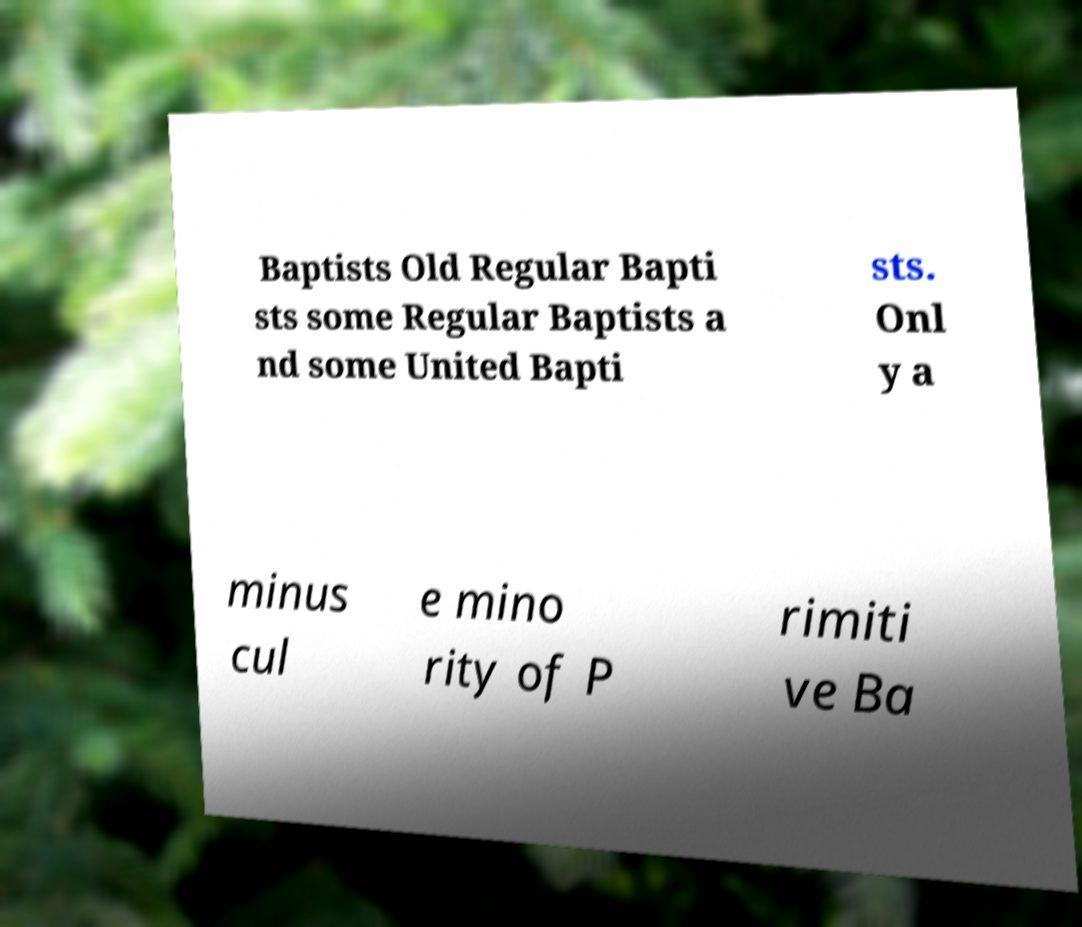What messages or text are displayed in this image? I need them in a readable, typed format. Baptists Old Regular Bapti sts some Regular Baptists a nd some United Bapti sts. Onl y a minus cul e mino rity of P rimiti ve Ba 